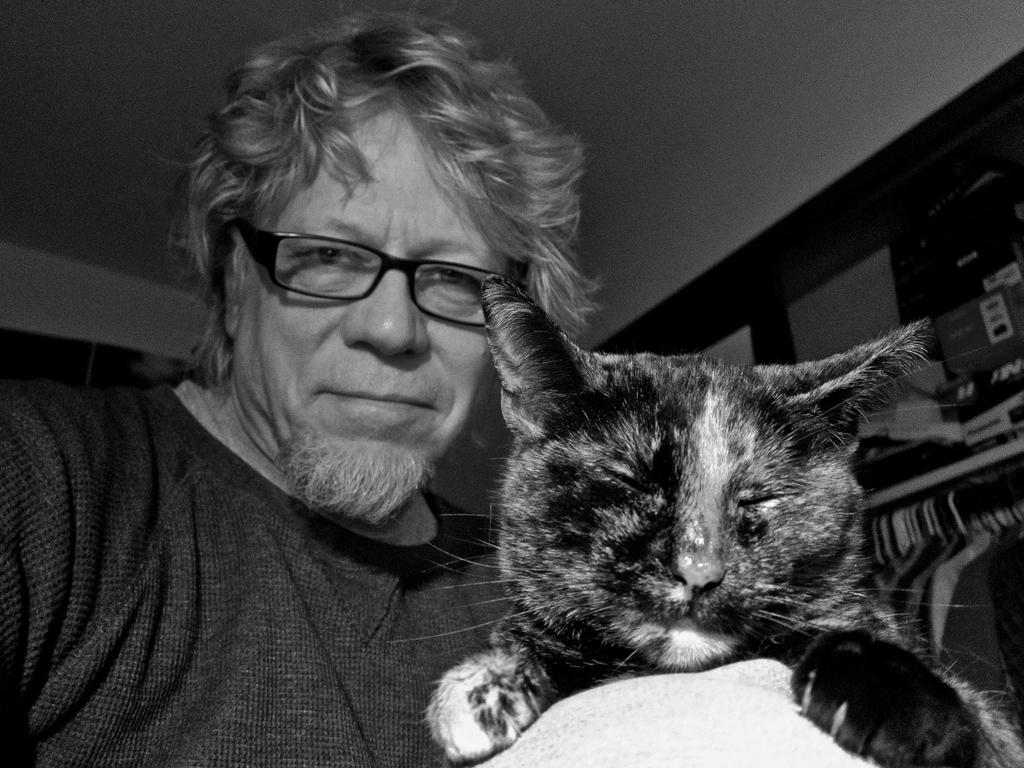What is the color scheme of the image? The image is black and white. What type of animal can be seen in the image? There is a cat in the image. Can you describe the person in the image? There is a person wearing spectacles in the image. What else can be seen in the image besides the cat and person? There are objects visible in the image. What type of mitten is the cat wearing in the image? There is no mitten present in the image, and the cat is not wearing any clothing. 